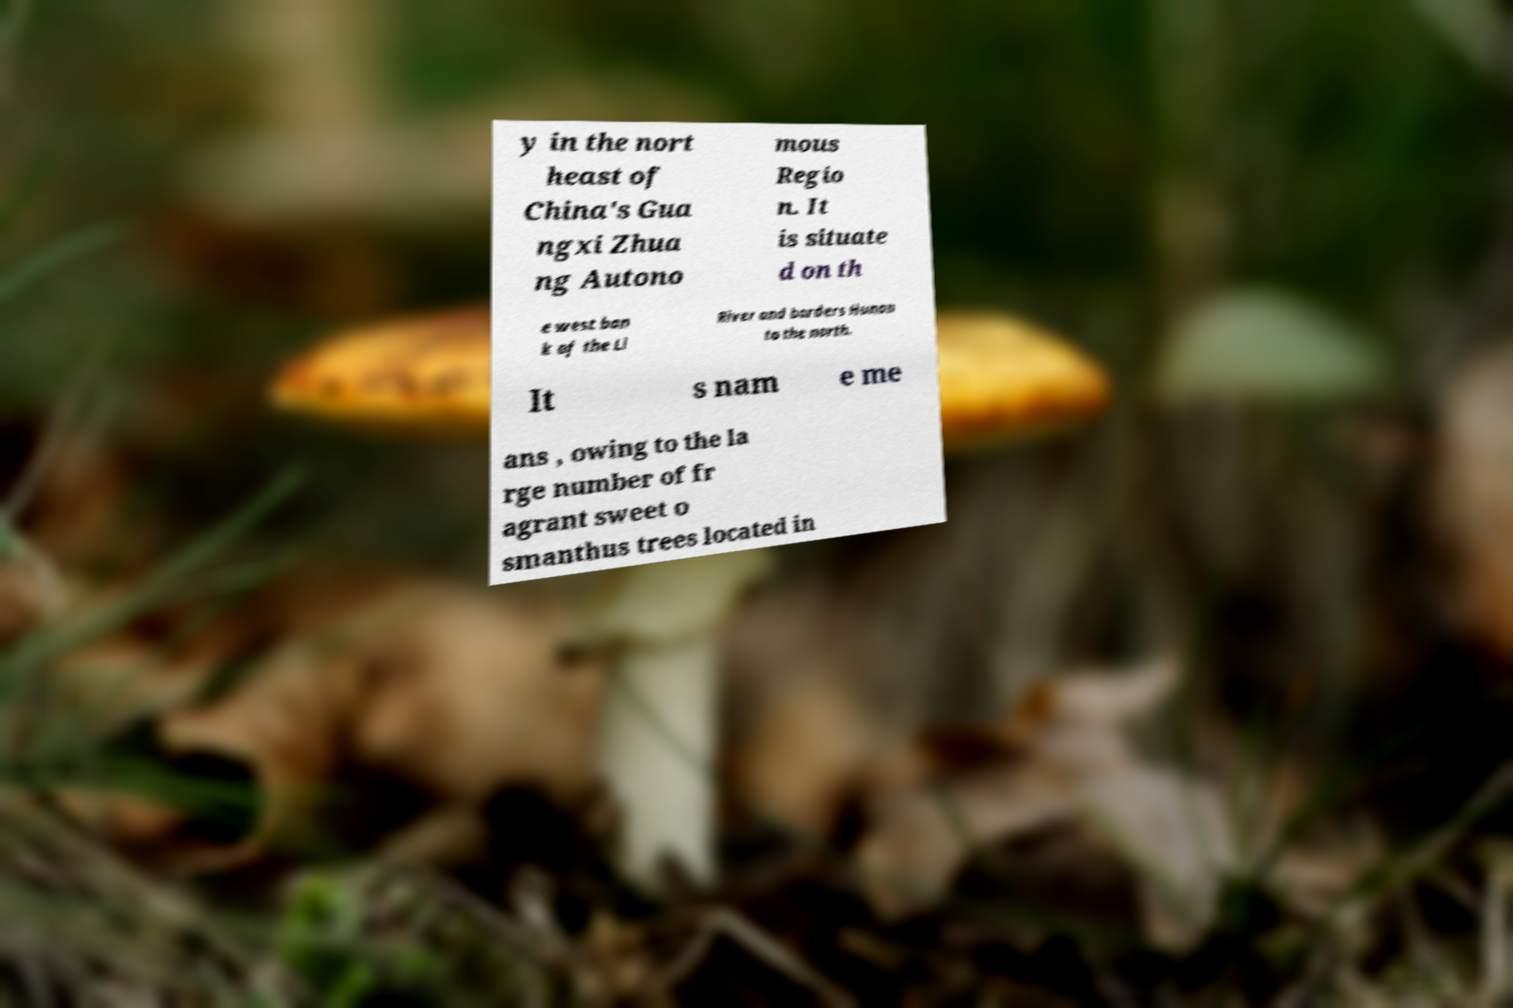Could you assist in decoding the text presented in this image and type it out clearly? y in the nort heast of China's Gua ngxi Zhua ng Autono mous Regio n. It is situate d on th e west ban k of the Li River and borders Hunan to the north. It s nam e me ans , owing to the la rge number of fr agrant sweet o smanthus trees located in 